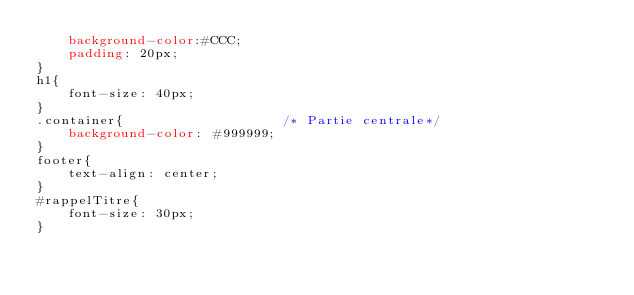<code> <loc_0><loc_0><loc_500><loc_500><_CSS_>    background-color:#CCC;
    padding: 20px;
}
h1{
    font-size: 40px;
}
.container{                    /* Partie centrale*/
    background-color: #999999;
}
footer{
    text-align: center;
}
#rappelTitre{
    font-size: 30px;
}
</code> 